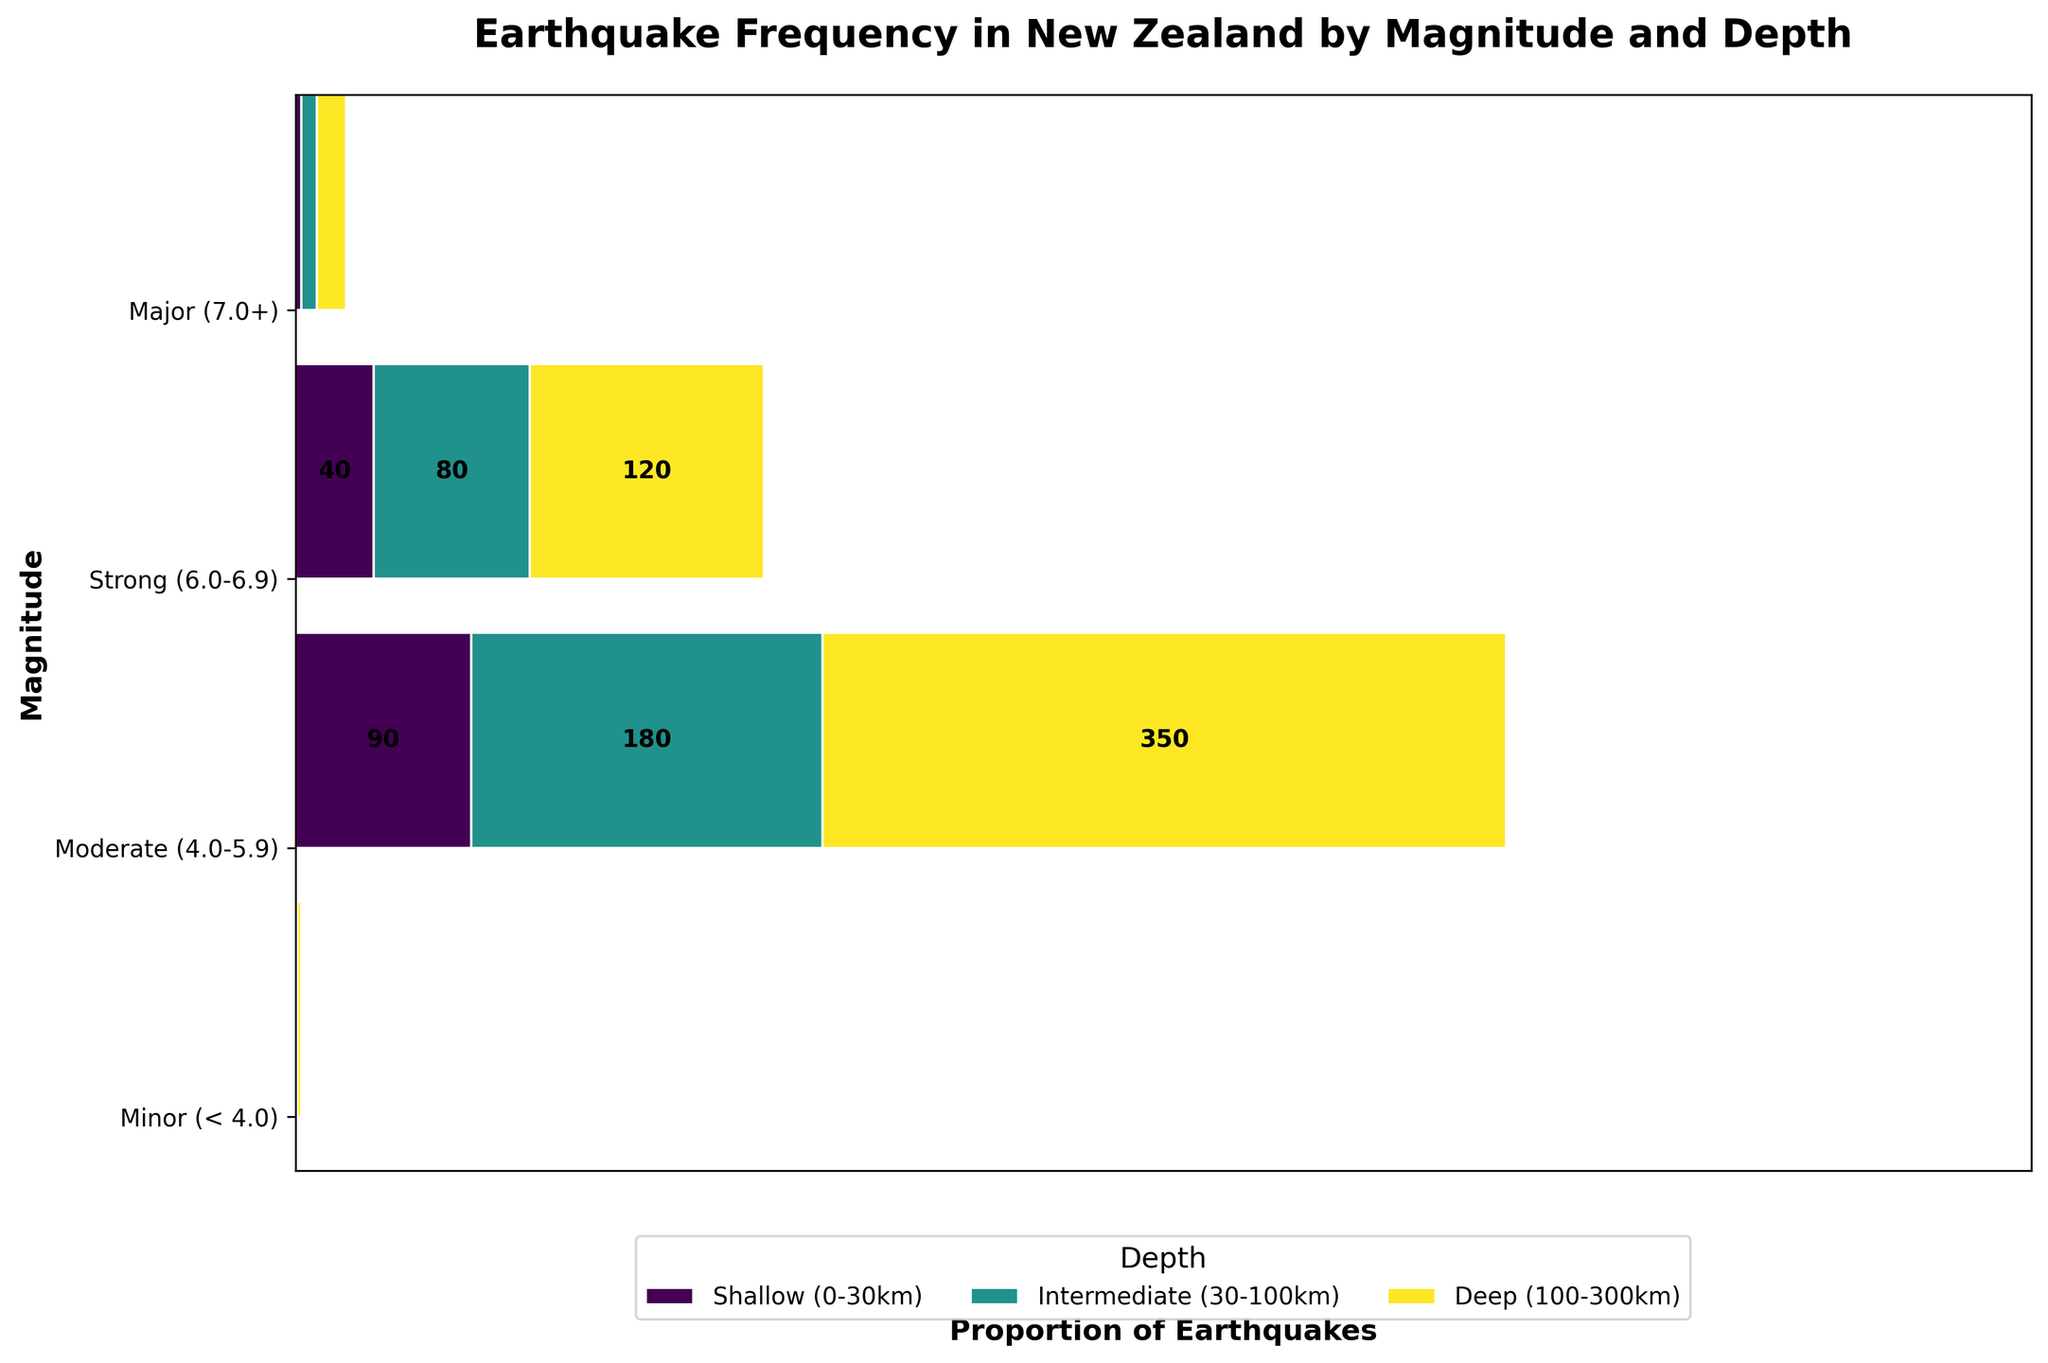What's the title of the plot? The title of the plot is usually displayed prominently at the top of the figure. In this case, it reads "Earthquake Frequency in New Zealand by Magnitude and Depth".
Answer: Earthquake Frequency in New Zealand by Magnitude and Depth How many total earthquake events are represented in the plot? To find the total number of earthquake events, sum up all the frequencies in the data table. The frequencies are 350, 180, 90, 120, 80, 40, 15, 8, 3, 2, 1, 0. Adding these together gives 350 + 180 + 90 + 120 + 80 + 40 + 15 + 8 + 3 + 2 + 1 = 889.
Answer: 889 Which magnitude category has the highest number of shallow earthquakes? The magnitude category with the highest number of shallow earthquakes is "Minor (< 4.0)" with a frequency of 350, as indicated by the corresponding bar size in the mosaic plot.
Answer: Minor (< 4.0) How many moderate earthquakes occurred at depths greater than 30 km? Looking at the plot, moderate earthquakes are in the "Moderate (4.0-5.9)" category. Summing up the frequencies for intermediate (30-100km) and deep (100-300km) depths, we get 80 + 40 = 120.
Answer: 120 Compare the frequencies of strong earthquakes at shallow and deep depths. Which one is higher? In the plot, strong earthquakes fall in the "Strong (6.0-6.9)" category. The frequency for shallow depths (15) is higher than that for deep depths (3), as represented by the wider bar for shallow depths.
Answer: Shallow (0-30km) What proportion of all earthquakes are minor and occur at intermediate depths? First, find the frequency of minor earthquakes at intermediate depths, which is 180. The total number of earthquakes is 889. The proportion is 180 / 889 which is approximately 0.202.
Answer: 0.202 How does the frequency of minor earthquakes at intermediate depths compare to major earthquakes at any depth? The frequency of minor earthquakes at intermediate depths is 180. The sum of frequencies for major earthquakes at all depths is 2 + 1 + 0 = 3. Thus, minor earthquakes at intermediate depths are much more frequent.
Answer: Minor earthquakes are much more frequent Are there any major earthquakes observed at deep depths? Referring to the plot, for the "Major (7.0+)" category at deep depths (100-300km), the frequency is 0. This indicates there are no major earthquakes observed at deep depths.
Answer: No Which depth category shows the highest number of total earthquakes, regardless of magnitude? To determine this, sum the frequencies across all magnitude categories for each depth. 
For shallow depths: 350 + 120 + 15 + 2 = 487 
For intermediate depths: 180 + 80 + 8 + 1 = 269 
For deep depths: 90 + 40 + 3 + 0 = 133 
The highest number of earthquakes occur at shallow depths.
Answer: Shallow (0-30km) What is the ratio of the number of shallow minor earthquakes to shallow moderate earthquakes? The frequency of shallow minor earthquakes is 350 and that of shallow moderate earthquakes is 120. The ratio is 350 / 120 which simplifies to approximately 7 / 2 or 3.5.
Answer: 3.5 